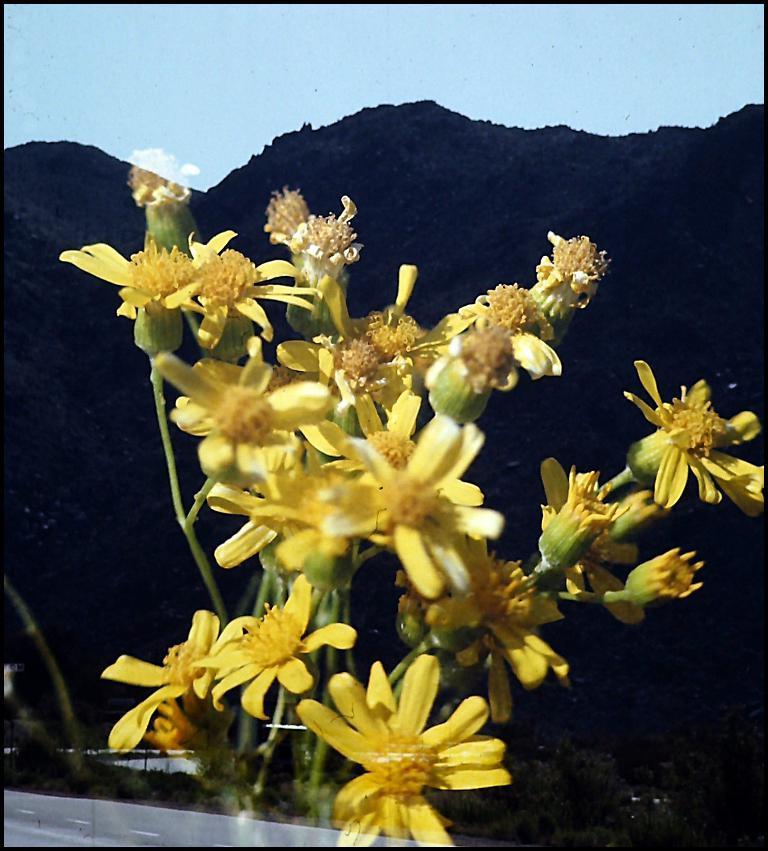How would you summarize this image in a sentence or two? In the picture we can see some flowers which are yellow in color and behind it, we can see the hills and the part of the sky with clouds. 